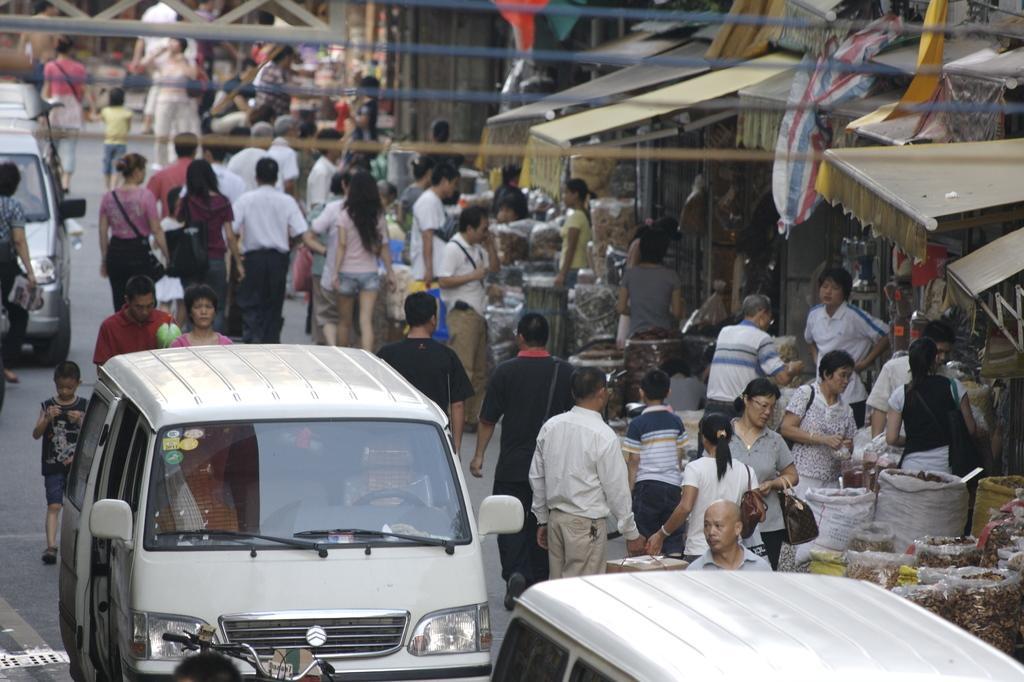Could you give a brief overview of what you see in this image? There are vehicles and group of people on the road. Here we can see stalls. 